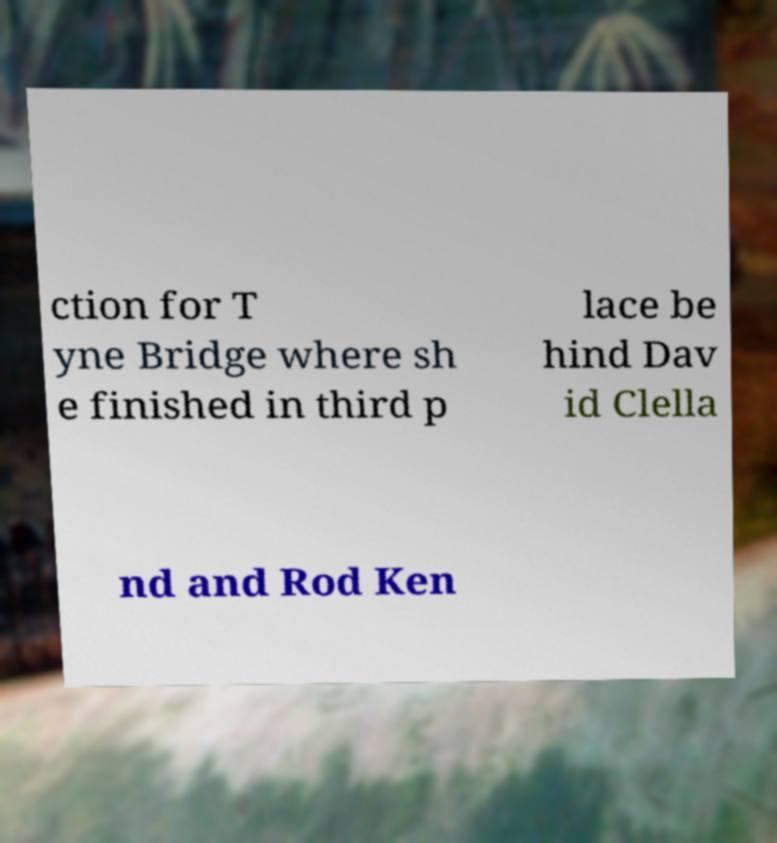Can you accurately transcribe the text from the provided image for me? ction for T yne Bridge where sh e finished in third p lace be hind Dav id Clella nd and Rod Ken 